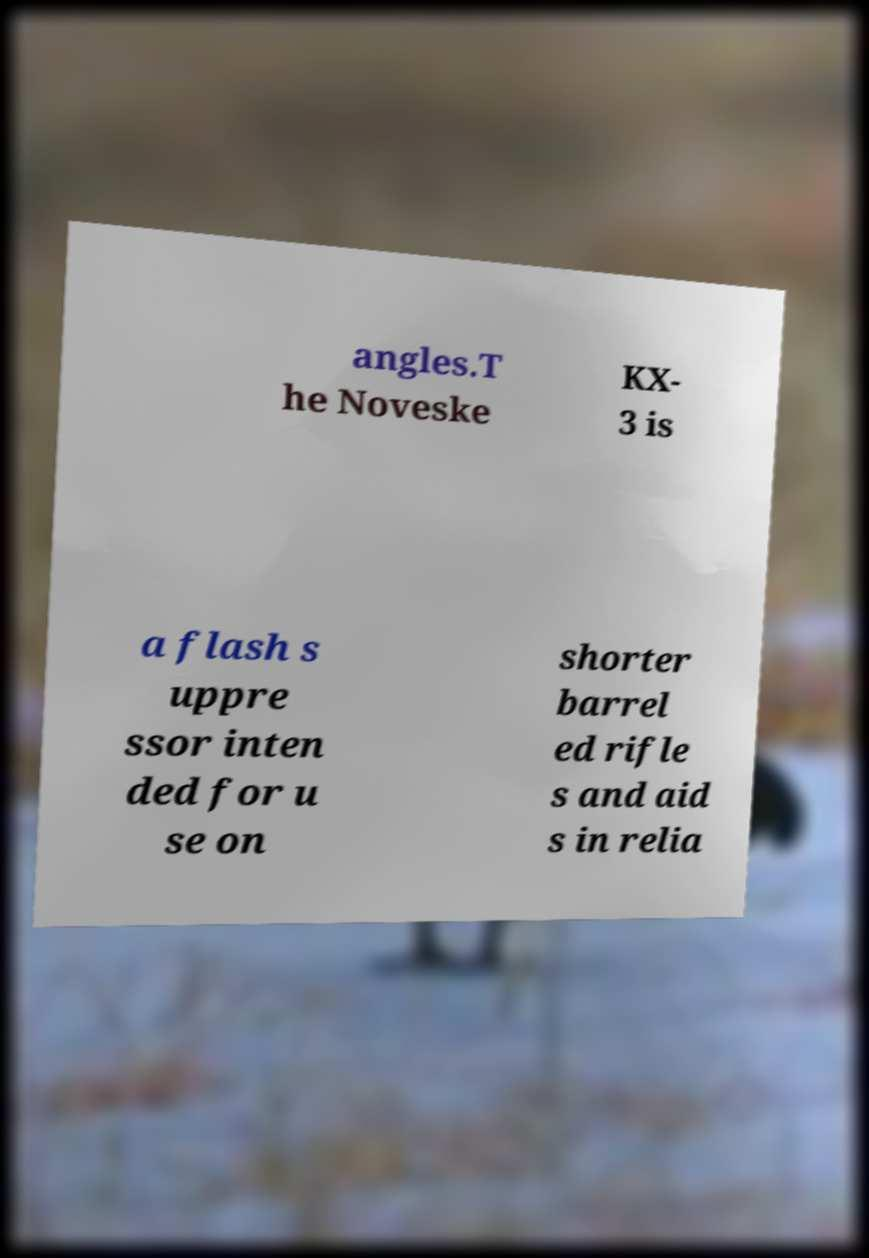For documentation purposes, I need the text within this image transcribed. Could you provide that? angles.T he Noveske KX- 3 is a flash s uppre ssor inten ded for u se on shorter barrel ed rifle s and aid s in relia 